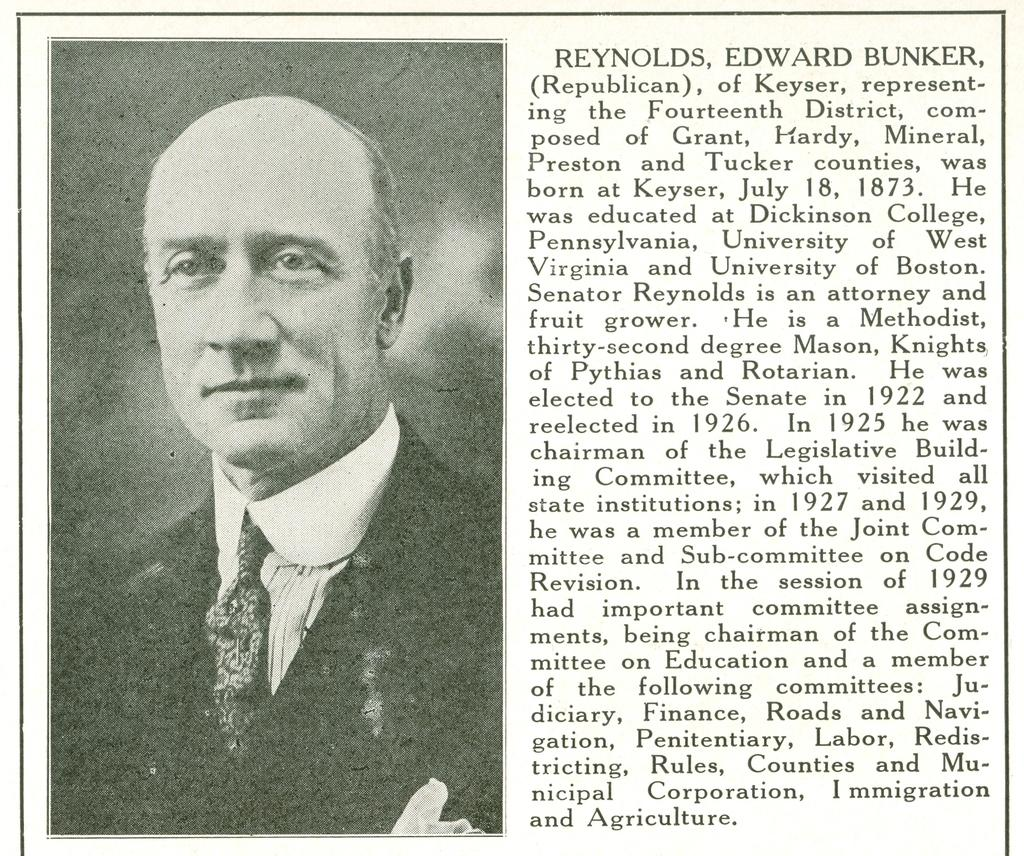What is the person in the left corner of the image wearing? The person in the left corner of the image is wearing a suit. What can be seen in the right corner of the image? There is something written in the right corner of the image. What type of pipe is the person smoking in the image? There is no pipe present in the image; the person is wearing a suit. What grade is the person in the image teaching in the office? There is no indication of a grade or an office in the image; it only shows a person wearing a suit and something written in the right corner. 